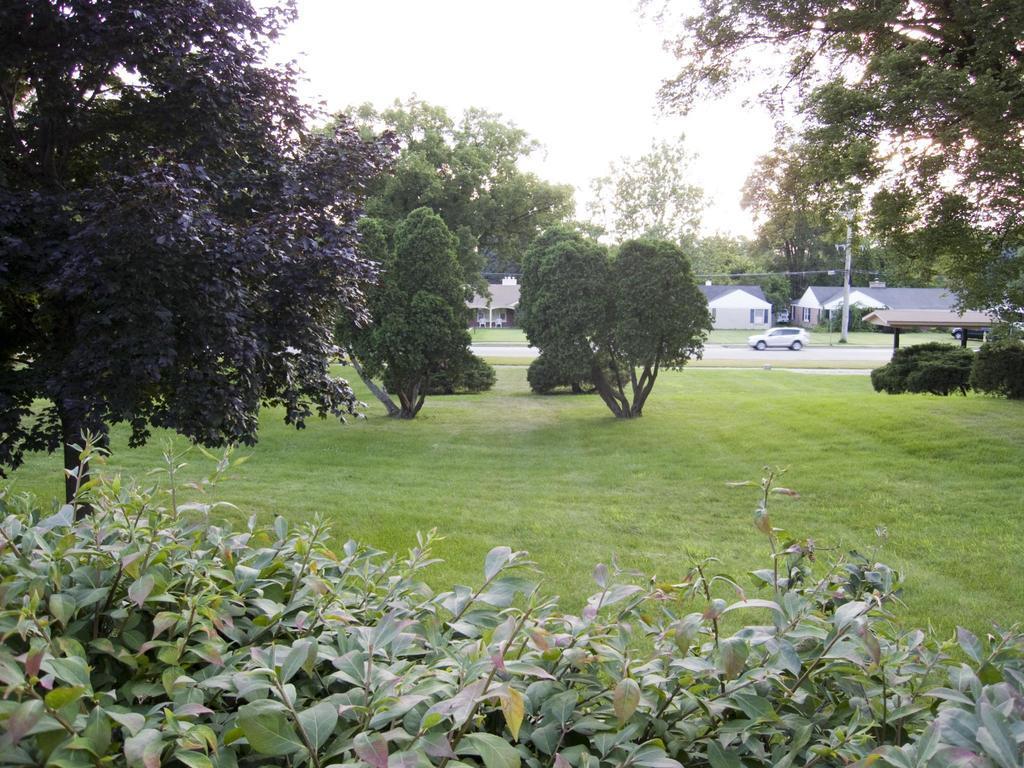Describe this image in one or two sentences. In the picture i can see some plants, trees, grass and in the background of the picture there is a car which is moving on road, i can see some houses, trees and top of the image there is clear sky. 